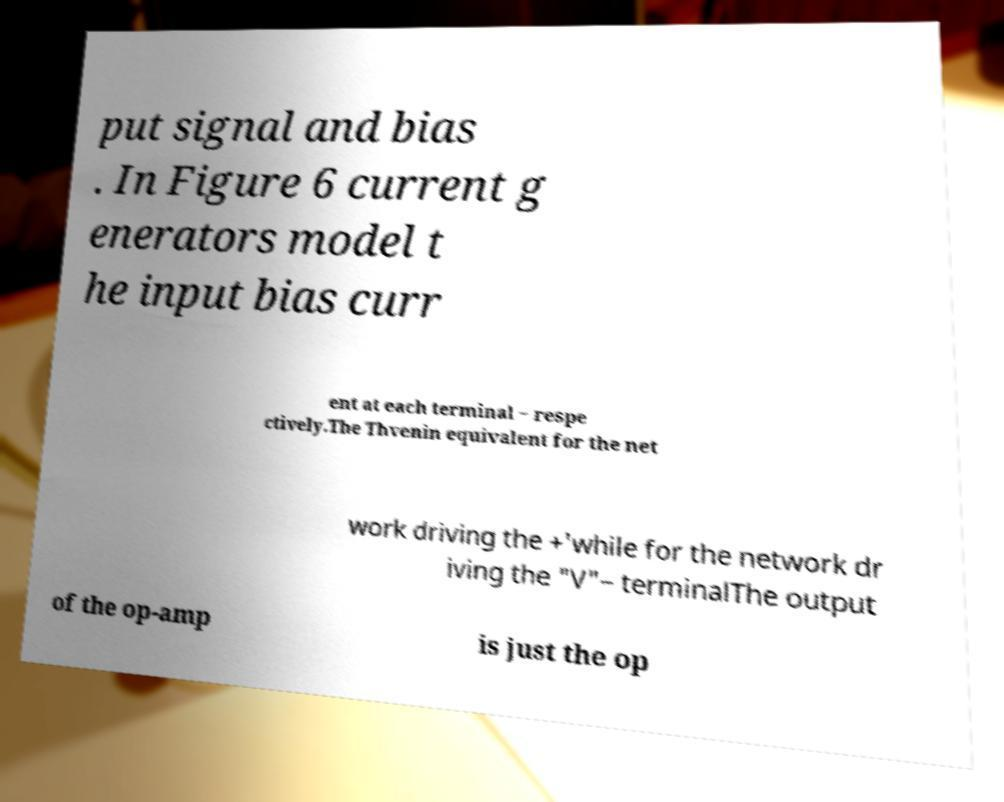Please identify and transcribe the text found in this image. put signal and bias . In Figure 6 current g enerators model t he input bias curr ent at each terminal − respe ctively.The Thvenin equivalent for the net work driving the +'while for the network dr iving the "V"− terminalThe output of the op-amp is just the op 